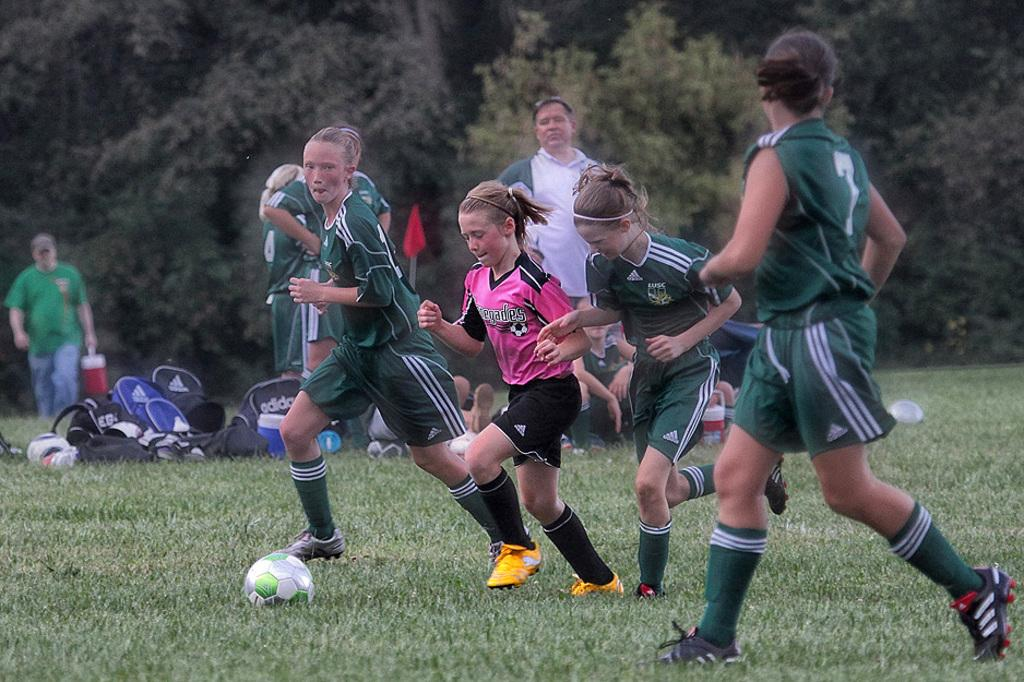What are the people in the image doing? There are people running and standing in the image. What might be the purpose of the bags placed on the grass? The bags placed on the grass might be for holding personal belongings or equipment. What object resembling a sport is present in the image? There is an object resembling a football present in the image. What can be seen in the background of the image? There are trees visible in the background. Can you tell me how many eggs are hidden in the cave in the image? There is no cave or eggs present in the image. What type of waves can be seen crashing on the shore in the image? There is no shore or waves present in the image. 